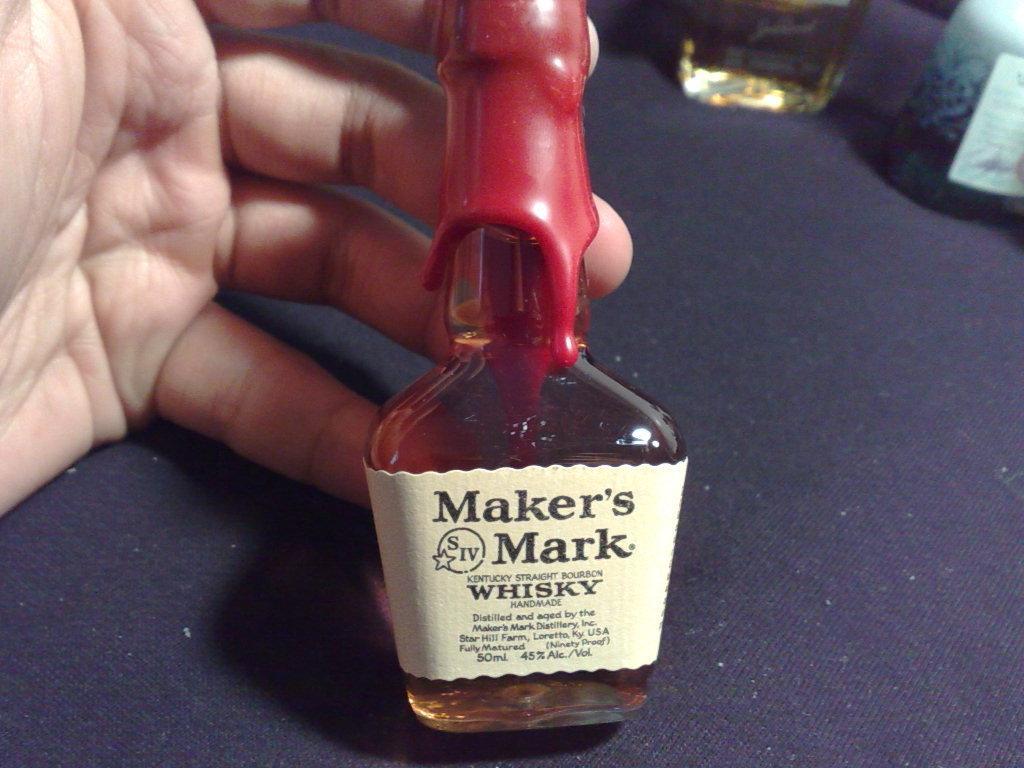How would you summarize this image in a sentence or two? In the image we can see there is a wine bottle in the hands of a person. 